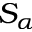<formula> <loc_0><loc_0><loc_500><loc_500>S _ { \alpha }</formula> 